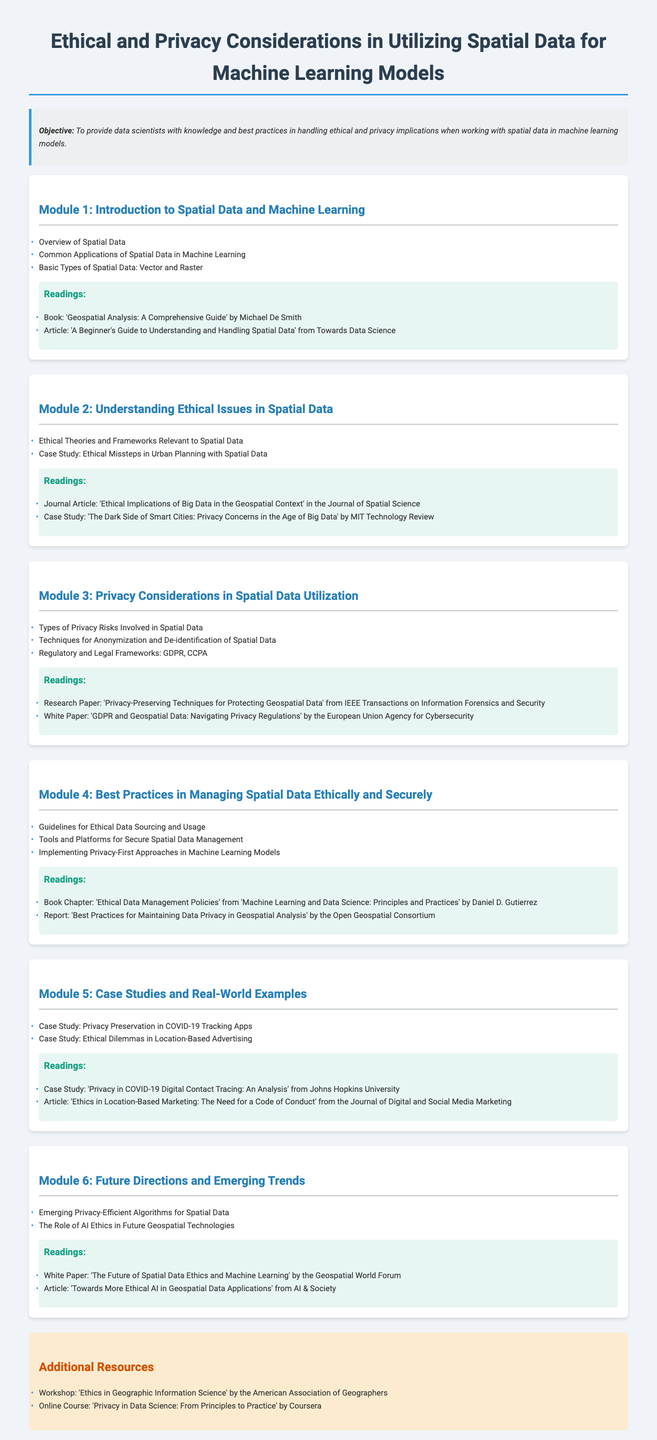What is the title of the syllabus? The title of the syllabus is prominently displayed at the top of the document.
Answer: Ethical and Privacy Considerations in Utilizing Spatial Data for Machine Learning Models What is the objective of the syllabus? The objective defines the main goal of the syllabus.
Answer: To provide data scientists with knowledge and best practices in handling ethical and privacy implications when working with spatial data in machine learning models How many modules are there in the syllabus? The syllabus lists multiple modules that detail various aspects of the topic.
Answer: 6 What is covered in Module 3? The details of what Module 3 includes can be found in the description of that module.
Answer: Privacy Considerations in Spatial Data Utilization Which reading is associated with ethical implications in big data? The readings section of Module 2 mentions specific articles and papers related to the topic.
Answer: Ethical Implications of Big Data in the Geospatial Context What case study is discussed in Module 5? This module includes a specific case study that addresses a current issue related to spatial data.
Answer: Privacy Preservation in COVID-19 Tracking Apps Which book is included in the readings for Module 4? The readings section for Module 4 lists specific books and chapters relevant to that module.
Answer: Ethical Data Management Policies What topic is the focus of Module 6? The title of Module 6 reveals the general focus area of that section.
Answer: Future Directions and Emerging Trends 